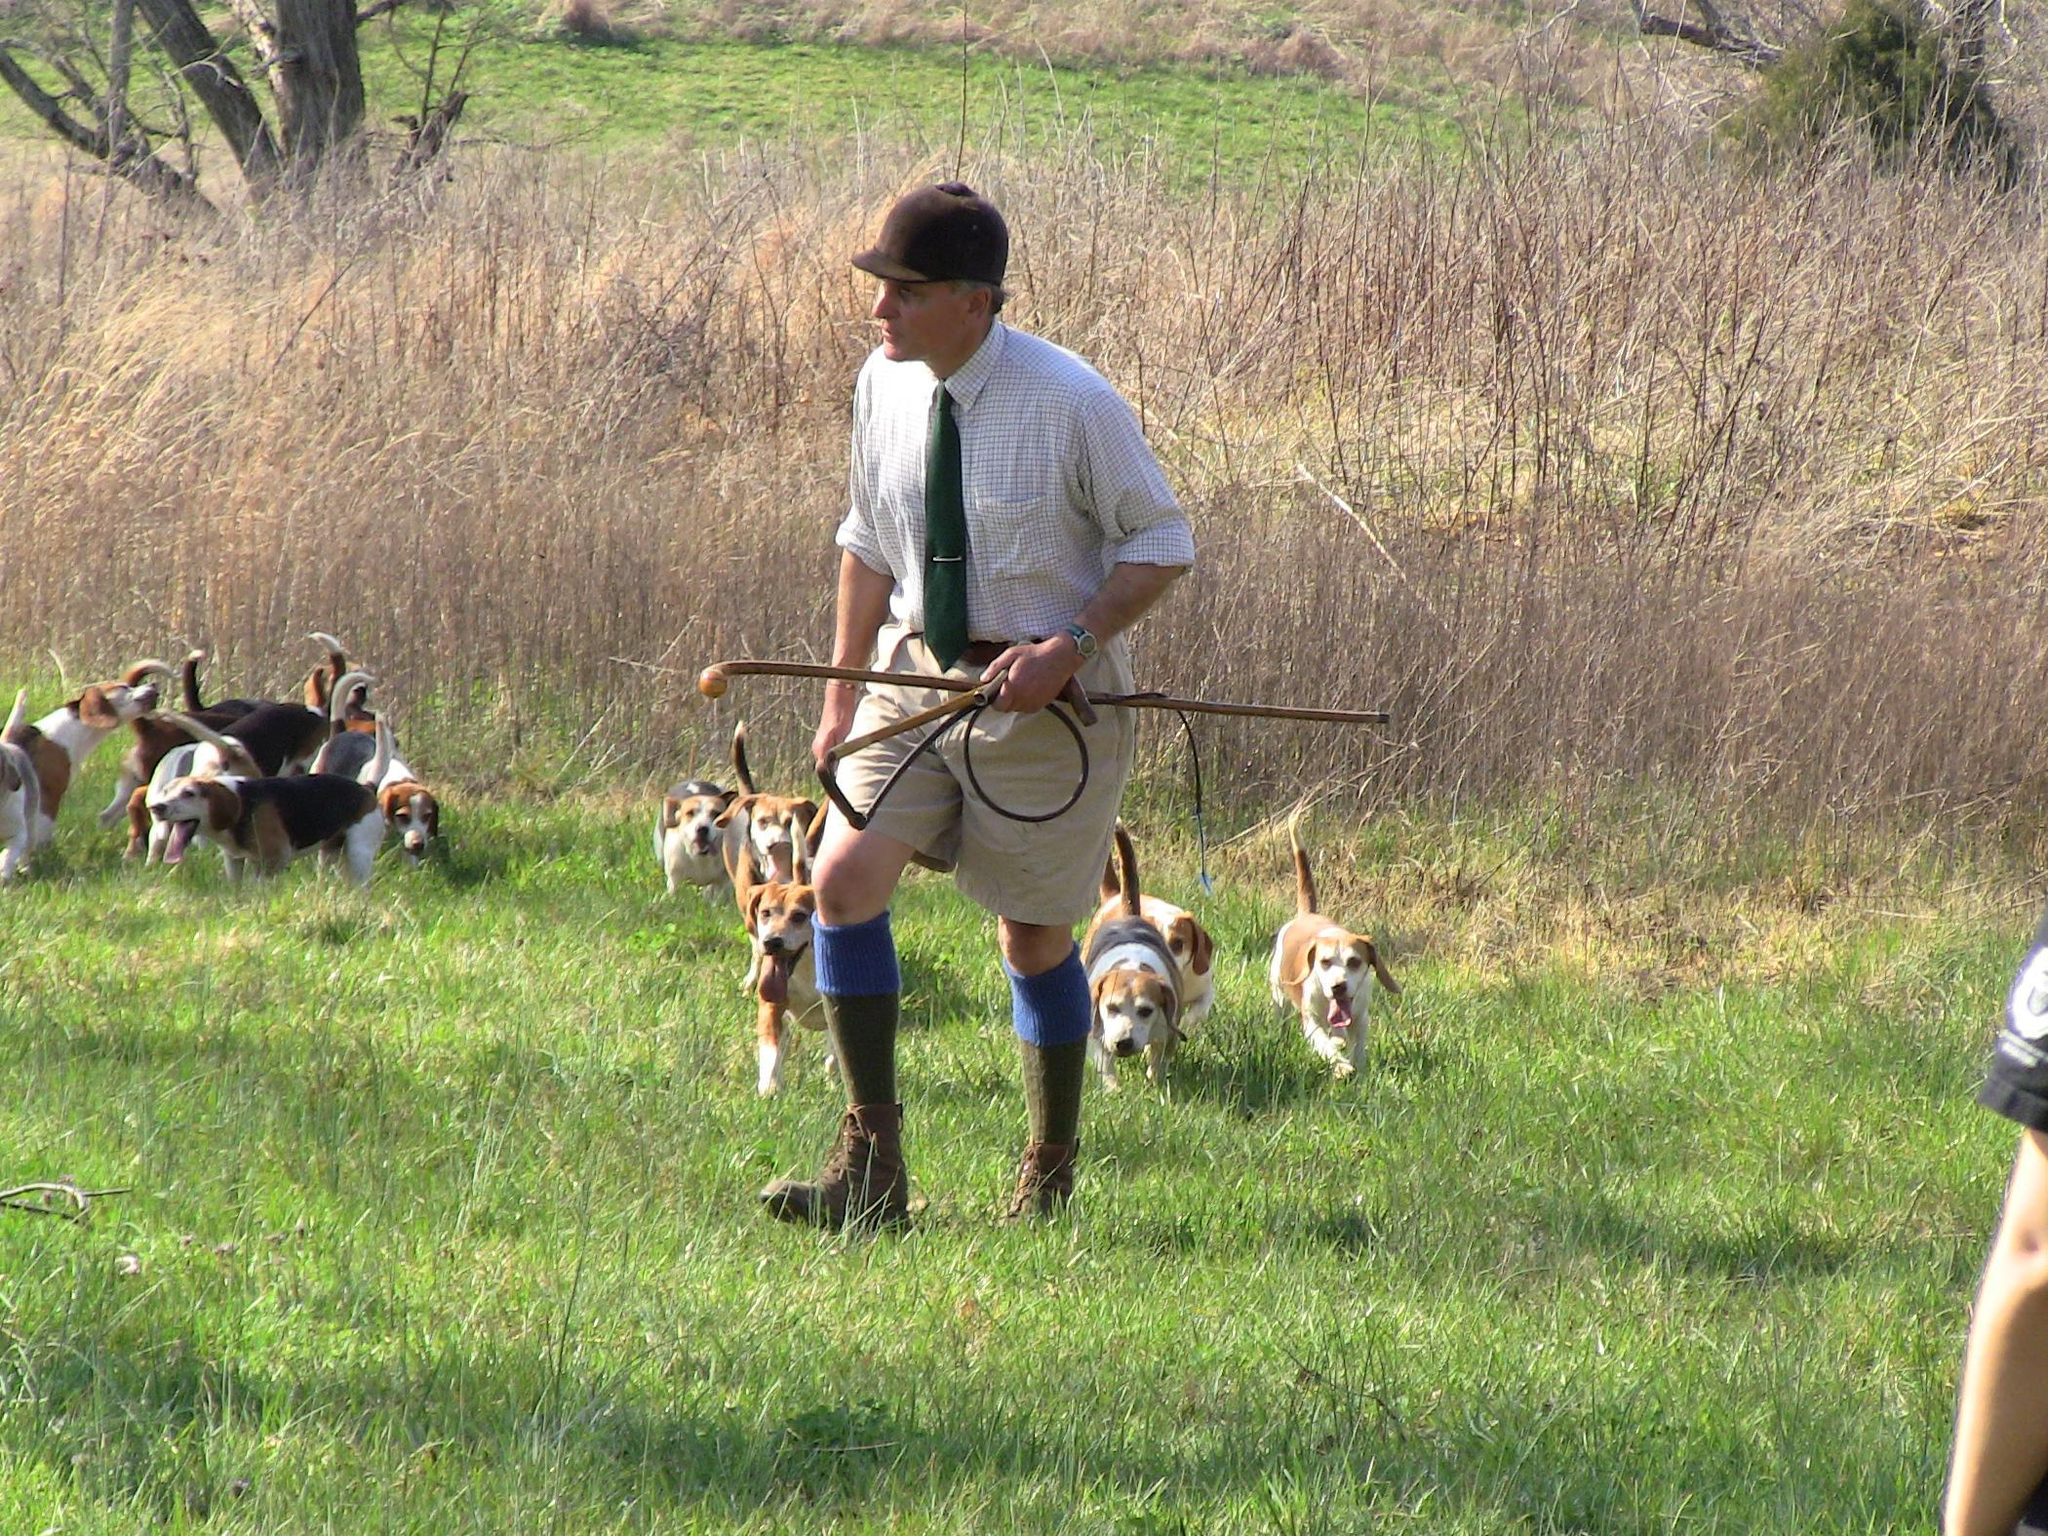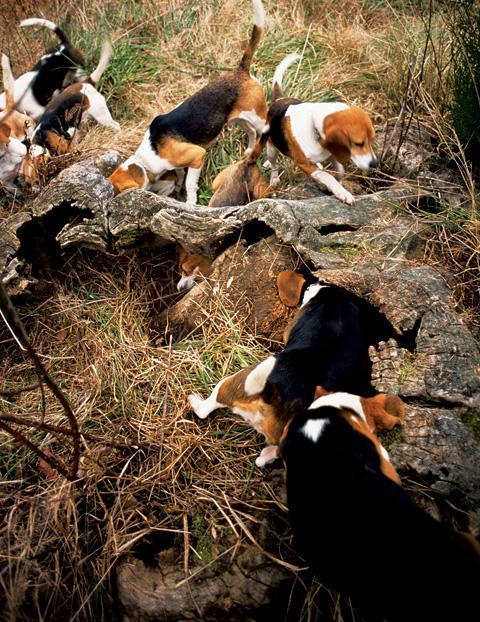The first image is the image on the left, the second image is the image on the right. Analyze the images presented: Is the assertion "In at least one of the images, a hunter in a bright orange vest and hat holds a dead animal over a beagle" valid? Answer yes or no. No. The first image is the image on the left, the second image is the image on the right. For the images shown, is this caption "At least one image shows a man in orange vest and cap holding up a prey animal over a hound dog." true? Answer yes or no. No. 